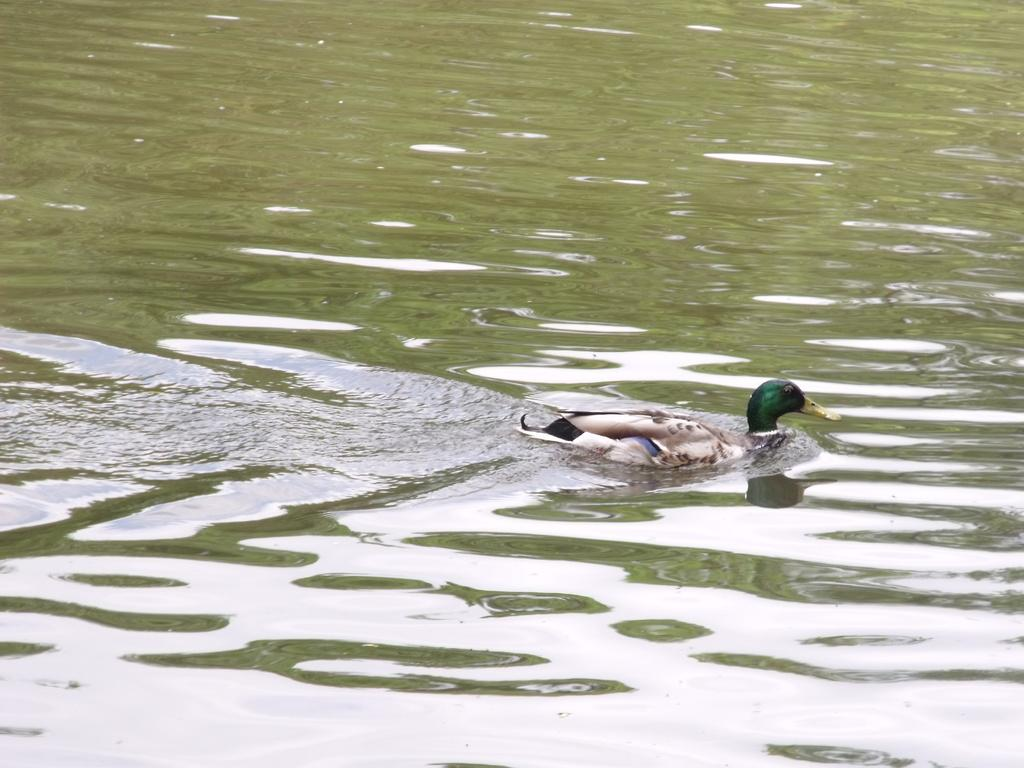What type of animal is present in the image? There is a bird in the image. Where is the bird located in the image? The bird is on the surface of the water. What type of bread is the bird holding in its beak in the image? There is no bread present in the image; the bird is simply on the surface of the water. How many chickens are visible in the image? There are no chickens present in the image; it features a bird on the surface of the water. 